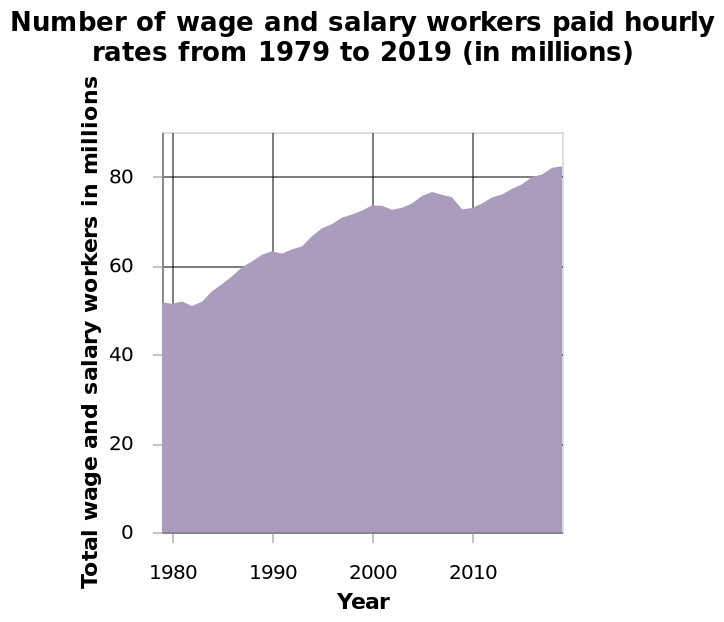<image>
Offer a thorough analysis of the image. In the graph, the trend is that there are more workers each year, which coincides with the ever growing population. This is what you would expect to see in such a graph. What is the name of the area chart?  The area chart is named "Number of wage and salary workers paid hourly rates from 1979 to 2019". When did the increase in the number of people being paid hourly start? The increase in the number of people being paid hourly started from the 1980s onwards. 